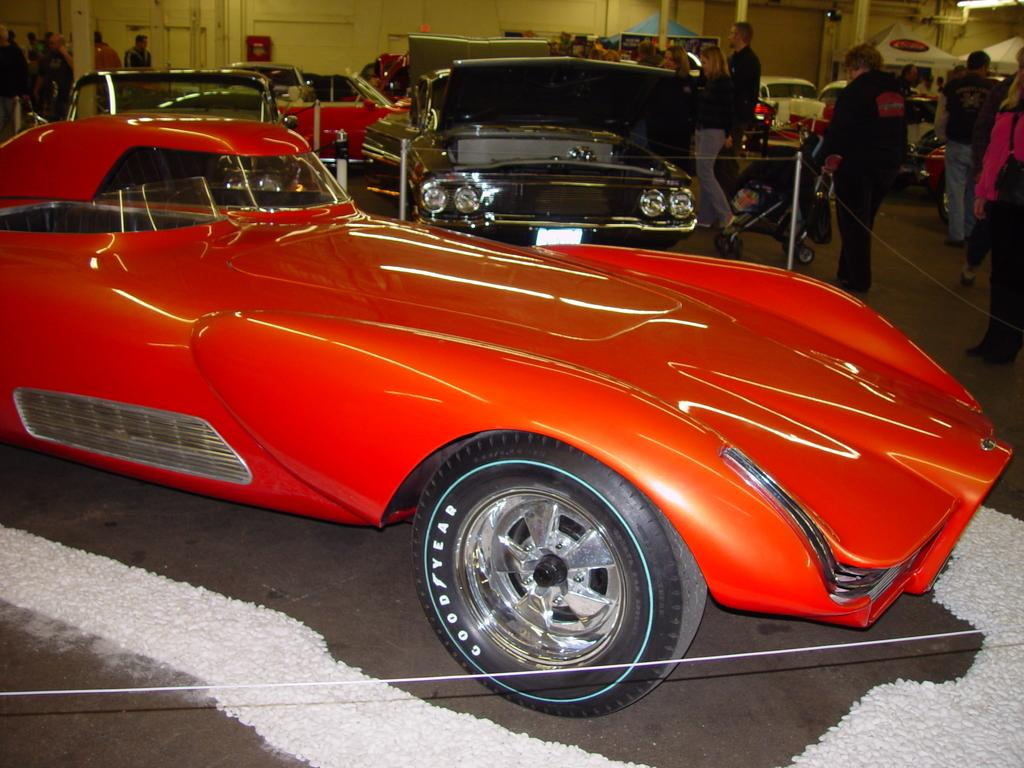What type of vehicles are present in the image? There are fleets of cars in the image. Where are the cars located? The cars are on the floor in the image. What else can be seen in the image besides the cars? There is a crowd visible in the image. What is visible in the background of the image? There is a wall visible in the background of the image. Where was the image taken? The image was taken in a showroom. Can you see the grandfather's toes in the image? There is no reference to a grandfather or toes in the image; it features fleets of cars in a showroom. 